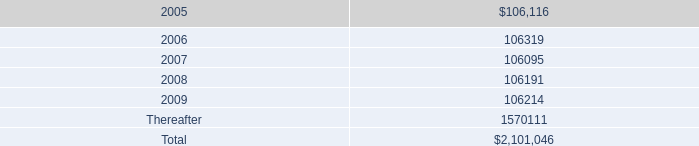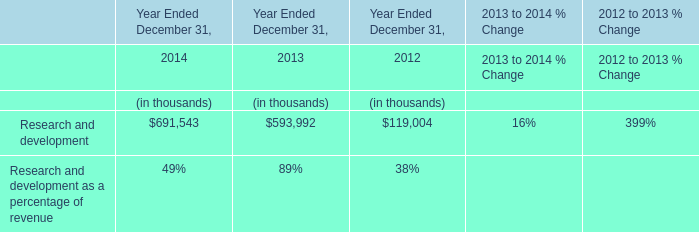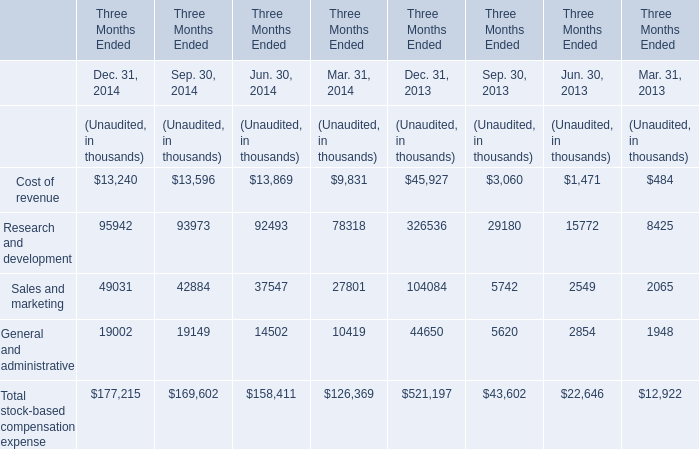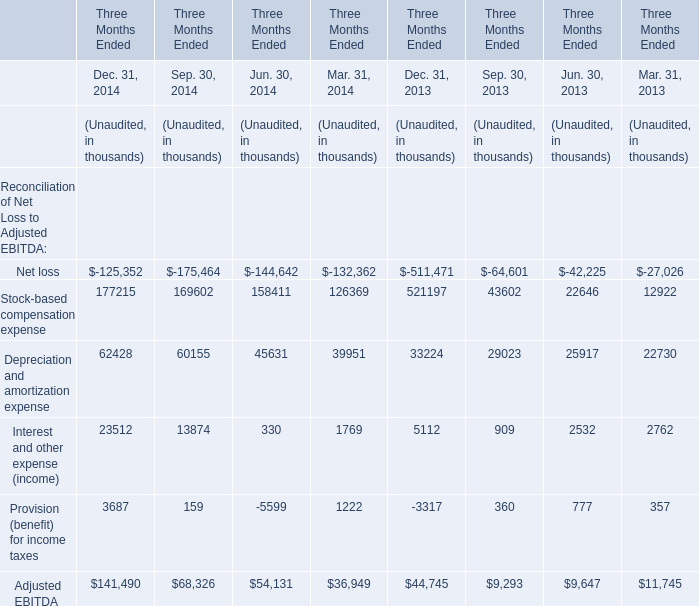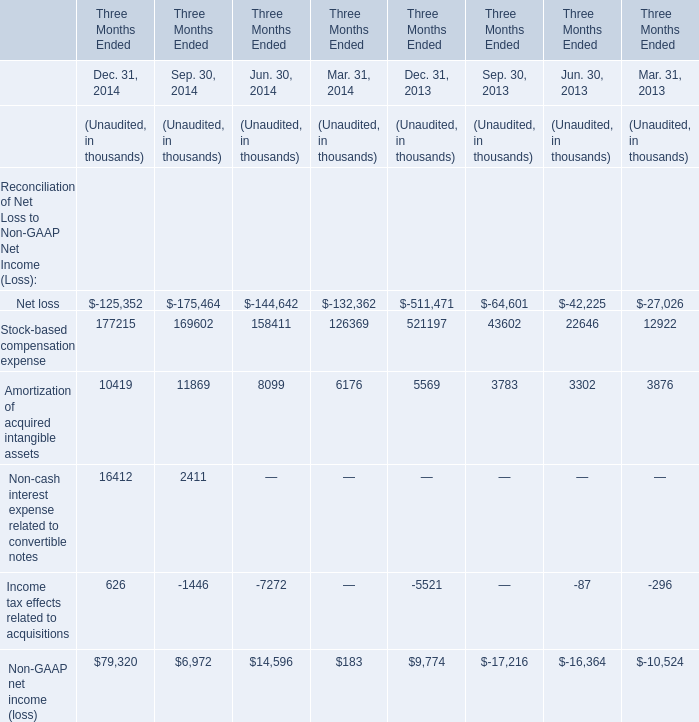What's the current increasing rate of Amortization of acquired intangible assets? (in %) 
Computations: ((10419 - 5569) / 5569)
Answer: 0.87089. 